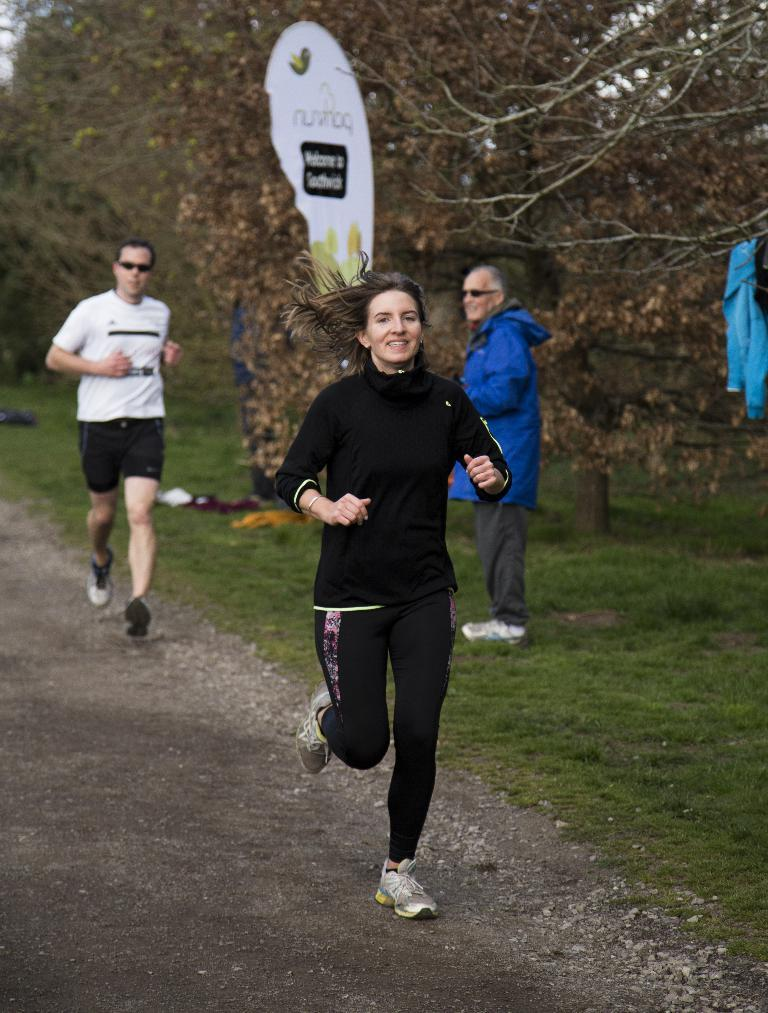How many people are present in the image? There are three people in the image: a man, a woman, and a person standing beside them. What are the man and the woman doing in the image? Both the man and the woman are running on the road in the image. What can be seen in the background of the image? Trees, a banner, and grass are visible in the image. What type of clothing can be seen in the image? Clothes are visible in the image. What type of circle is being taught by the person standing beside them in the image? There is no circle or teaching activity present in the image. What type of shirt is the man wearing in the image? The provided facts do not mention the type of shirt the man is wearing in the image. 